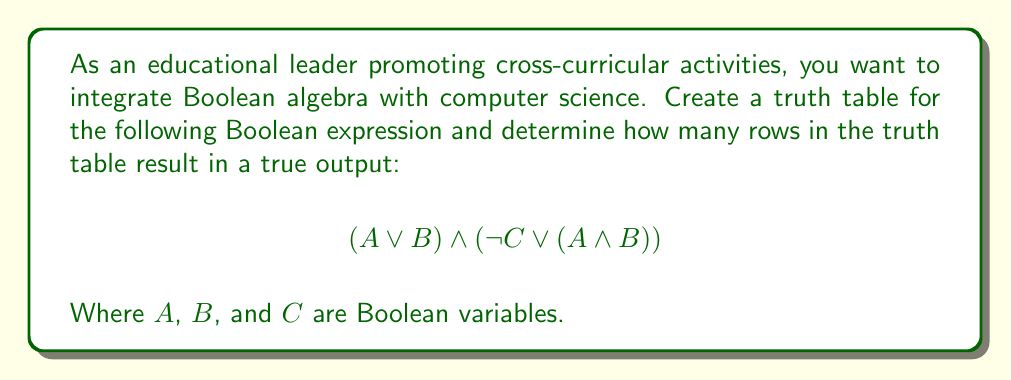Give your solution to this math problem. Let's approach this step-by-step:

1) First, we need to create a truth table for this expression. With 3 variables (A, B, C), we'll have $2^3 = 8$ rows.

2) Let's break down the expression into parts:
   Part 1: $(A \lor B)$
   Part 2: $(\lnot C \lor (A \land B))$
   Final: Part 1 $\land$ Part 2

3) Create the truth table:

   | A | B | C | $(A \lor B)$ | $(A \land B)$ | $\lnot C$ | $(\lnot C \lor (A \land B))$ | $(A \lor B) \land (\lnot C \lor (A \land B))$ |
   |---|---|---|--------------|---------------|-----------|------------------------------|-----------------------------------------------|
   | 0 | 0 | 0 | 0            | 0             | 1         | 1                            | 0                                             |
   | 0 | 0 | 1 | 0            | 0             | 0         | 0                            | 0                                             |
   | 0 | 1 | 0 | 1            | 0             | 1         | 1                            | 1                                             |
   | 0 | 1 | 1 | 1            | 0             | 0         | 0                            | 0                                             |
   | 1 | 0 | 0 | 1            | 0             | 1         | 1                            | 1                                             |
   | 1 | 0 | 1 | 1            | 0             | 0         | 0                            | 0                                             |
   | 1 | 1 | 0 | 1            | 1             | 1         | 1                            | 1                                             |
   | 1 | 1 | 1 | 1            | 1             | 0         | 1                            | 1                                             |

4) Count the number of true (1) outputs in the final column: There are 4 rows that result in a true output.
Answer: 4 